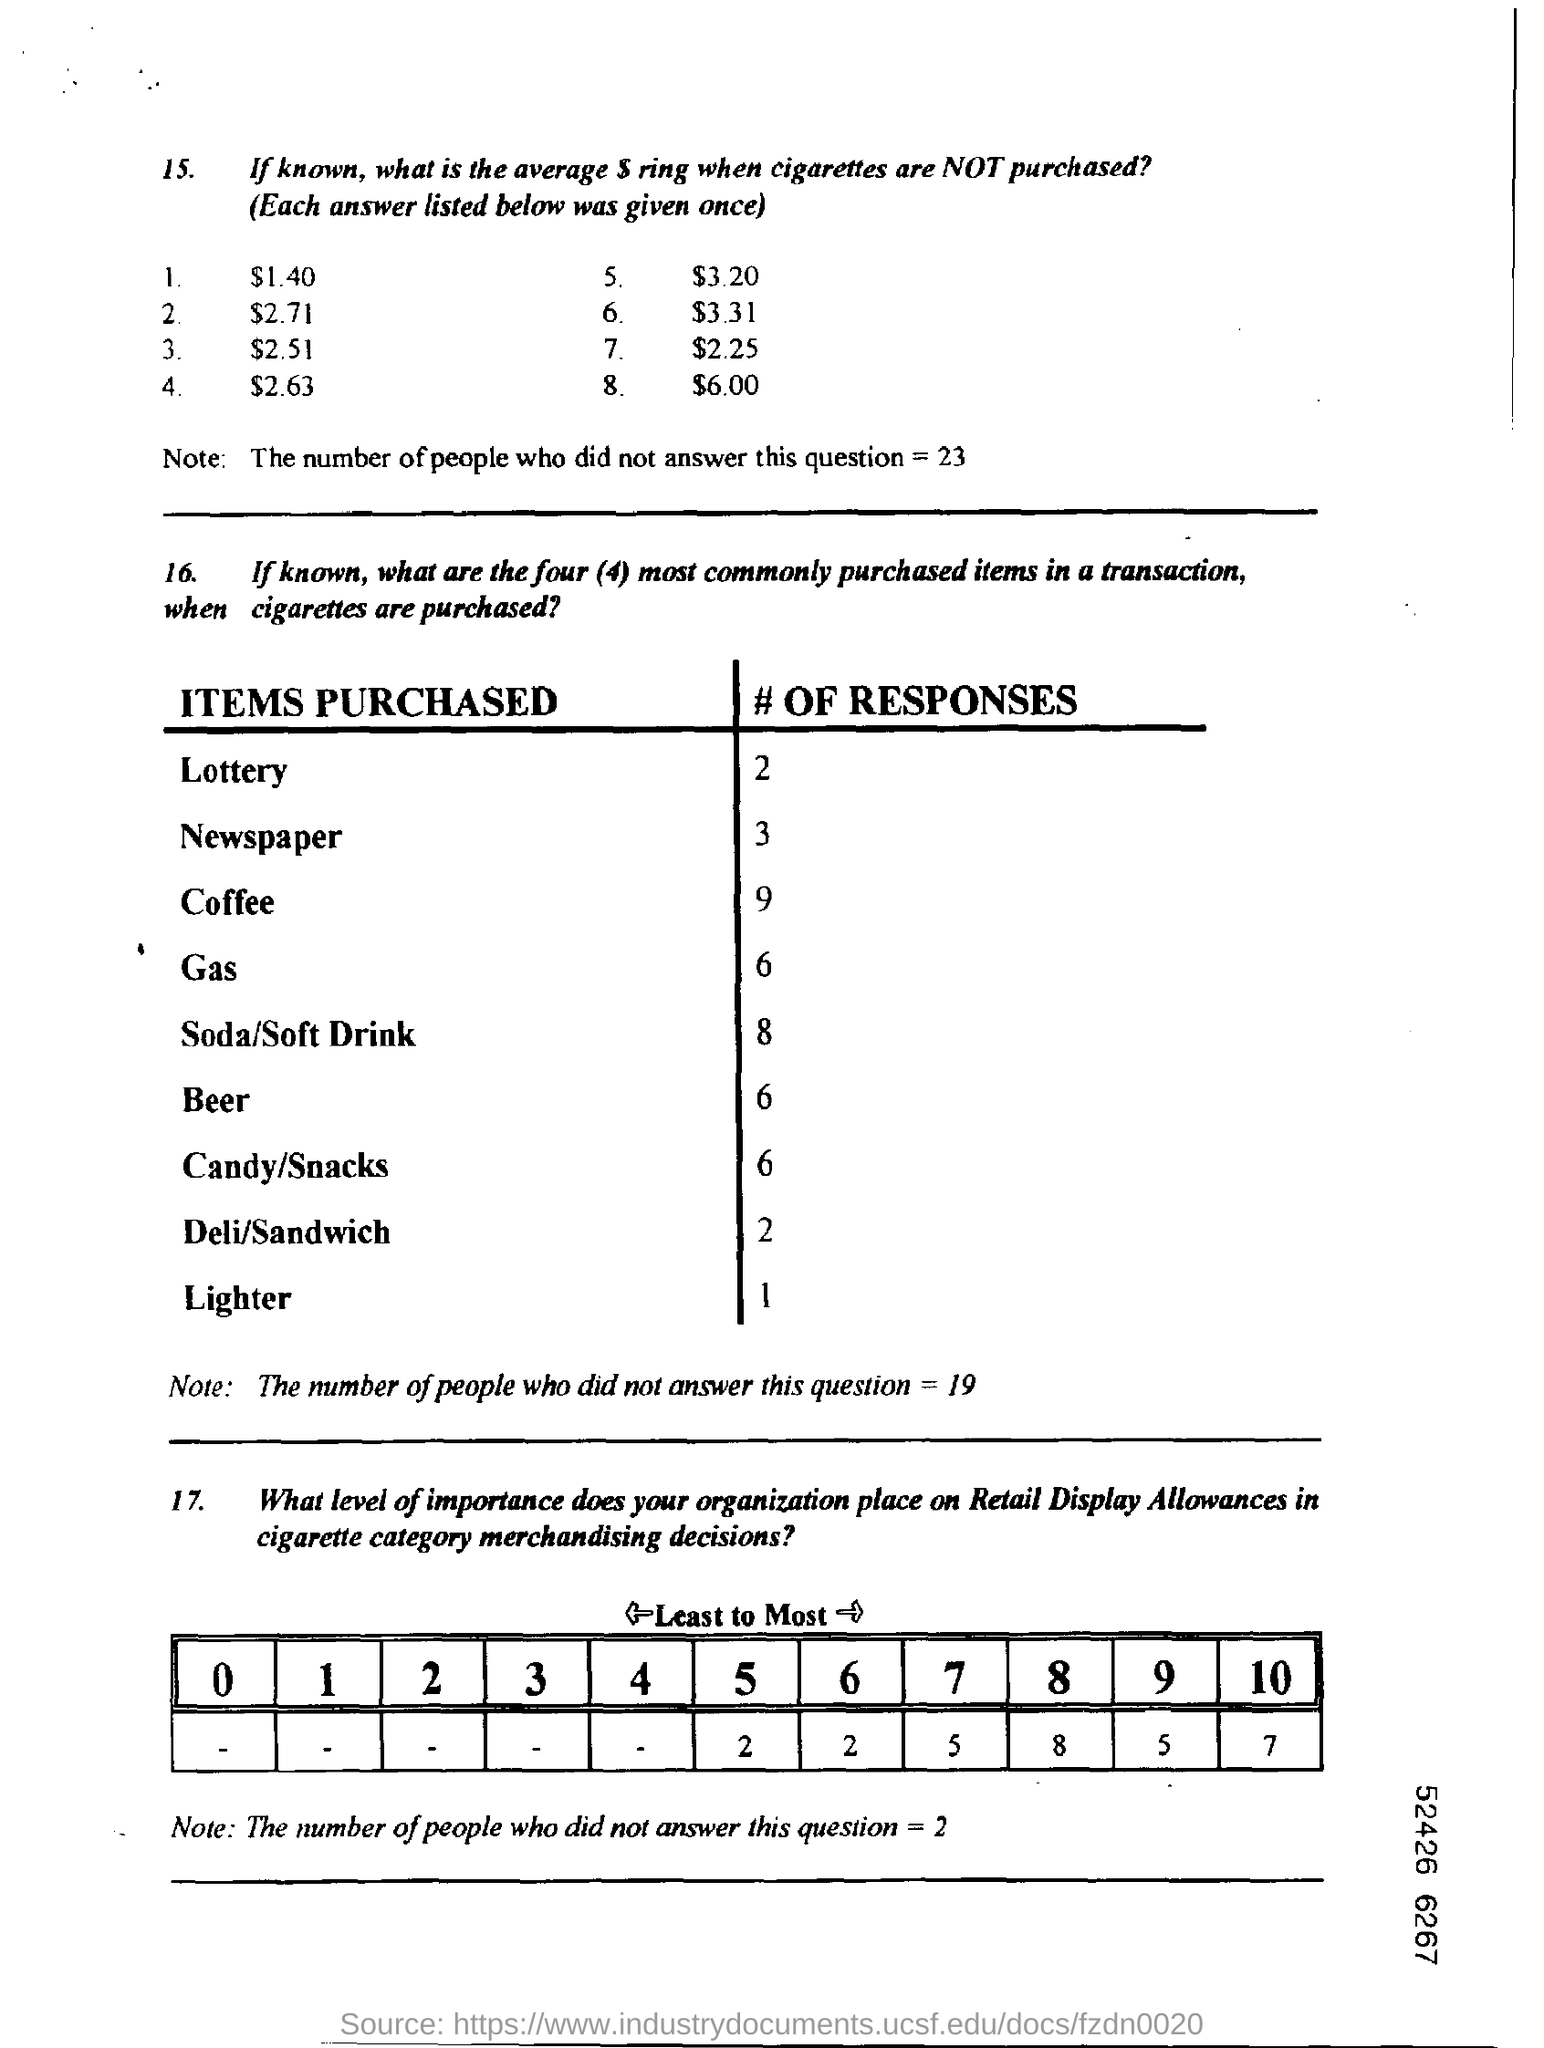How many people did not answer question 15?
Your answer should be very brief. 23. How many responses did coffee get?
Provide a succinct answer. 9. 